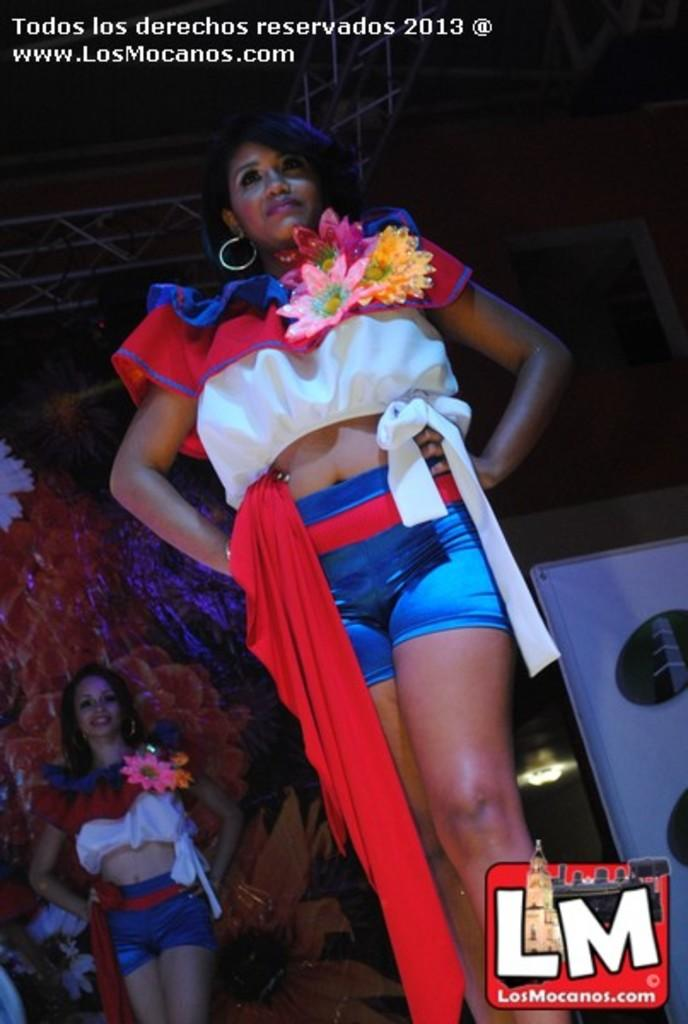Provide a one-sentence caption for the provided image. A woman in a red/white top and blue shorts with hands on hip and in the lower right corner there's a logo for "losmocanos.com". 